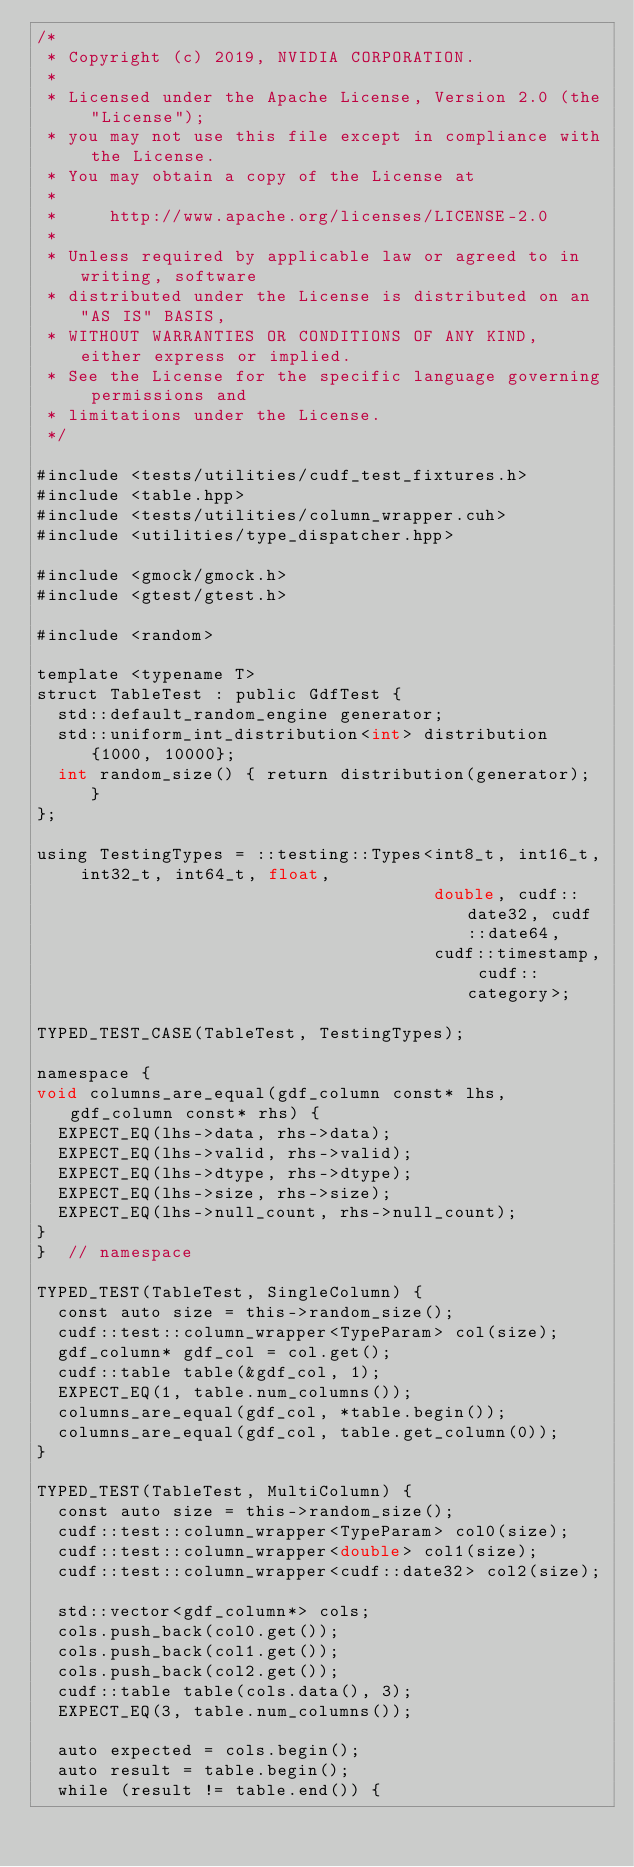Convert code to text. <code><loc_0><loc_0><loc_500><loc_500><_Cuda_>/*
 * Copyright (c) 2019, NVIDIA CORPORATION.
 *
 * Licensed under the Apache License, Version 2.0 (the "License");
 * you may not use this file except in compliance with the License.
 * You may obtain a copy of the License at
 *
 *     http://www.apache.org/licenses/LICENSE-2.0
 *
 * Unless required by applicable law or agreed to in writing, software
 * distributed under the License is distributed on an "AS IS" BASIS,
 * WITHOUT WARRANTIES OR CONDITIONS OF ANY KIND, either express or implied.
 * See the License for the specific language governing permissions and
 * limitations under the License.
 */

#include <tests/utilities/cudf_test_fixtures.h>
#include <table.hpp>
#include <tests/utilities/column_wrapper.cuh>
#include <utilities/type_dispatcher.hpp>

#include <gmock/gmock.h>
#include <gtest/gtest.h>

#include <random>

template <typename T>
struct TableTest : public GdfTest {
  std::default_random_engine generator;
  std::uniform_int_distribution<int> distribution{1000, 10000};
  int random_size() { return distribution(generator); }
};

using TestingTypes = ::testing::Types<int8_t, int16_t, int32_t, int64_t, float,
                                      double, cudf::date32, cudf::date64,
                                      cudf::timestamp, cudf::category>;

TYPED_TEST_CASE(TableTest, TestingTypes);

namespace {
void columns_are_equal(gdf_column const* lhs, gdf_column const* rhs) {
  EXPECT_EQ(lhs->data, rhs->data);
  EXPECT_EQ(lhs->valid, rhs->valid);
  EXPECT_EQ(lhs->dtype, rhs->dtype);
  EXPECT_EQ(lhs->size, rhs->size);
  EXPECT_EQ(lhs->null_count, rhs->null_count);
}
}  // namespace

TYPED_TEST(TableTest, SingleColumn) {
  const auto size = this->random_size();
  cudf::test::column_wrapper<TypeParam> col(size);
  gdf_column* gdf_col = col.get();
  cudf::table table(&gdf_col, 1);
  EXPECT_EQ(1, table.num_columns());
  columns_are_equal(gdf_col, *table.begin());
  columns_are_equal(gdf_col, table.get_column(0));
}

TYPED_TEST(TableTest, MultiColumn) {
  const auto size = this->random_size();
  cudf::test::column_wrapper<TypeParam> col0(size);
  cudf::test::column_wrapper<double> col1(size);
  cudf::test::column_wrapper<cudf::date32> col2(size);

  std::vector<gdf_column*> cols;
  cols.push_back(col0.get());
  cols.push_back(col1.get());
  cols.push_back(col2.get());
  cudf::table table(cols.data(), 3);
  EXPECT_EQ(3, table.num_columns());

  auto expected = cols.begin();
  auto result = table.begin();
  while (result != table.end()) {</code> 